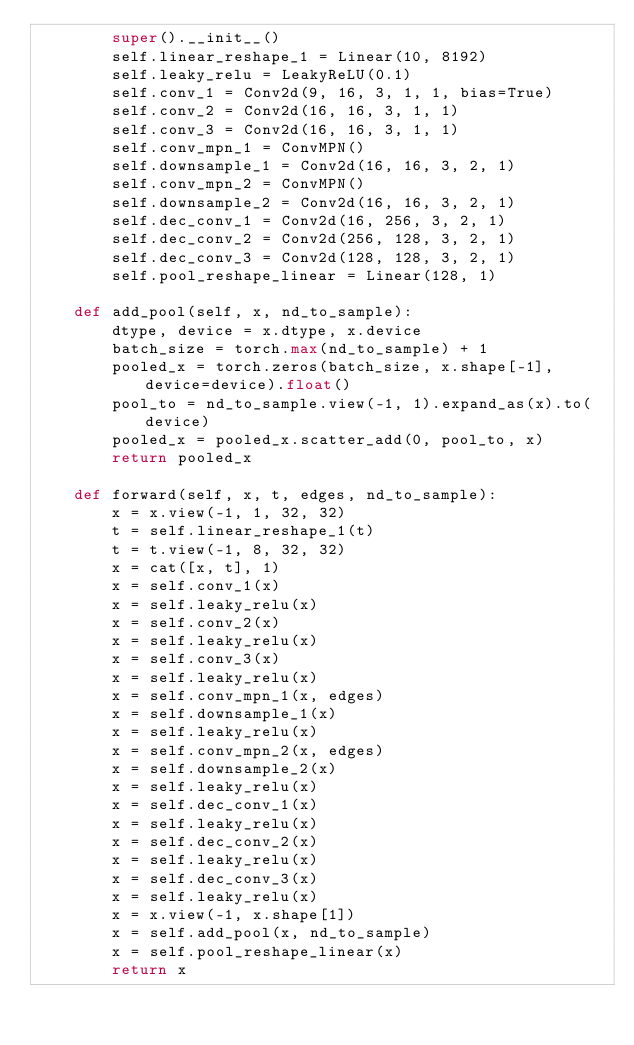<code> <loc_0><loc_0><loc_500><loc_500><_Python_>        super().__init__()
        self.linear_reshape_1 = Linear(10, 8192)
        self.leaky_relu = LeakyReLU(0.1)
        self.conv_1 = Conv2d(9, 16, 3, 1, 1, bias=True)
        self.conv_2 = Conv2d(16, 16, 3, 1, 1)
        self.conv_3 = Conv2d(16, 16, 3, 1, 1)
        self.conv_mpn_1 = ConvMPN()
        self.downsample_1 = Conv2d(16, 16, 3, 2, 1)
        self.conv_mpn_2 = ConvMPN()
        self.downsample_2 = Conv2d(16, 16, 3, 2, 1)
        self.dec_conv_1 = Conv2d(16, 256, 3, 2, 1)
        self.dec_conv_2 = Conv2d(256, 128, 3, 2, 1)
        self.dec_conv_3 = Conv2d(128, 128, 3, 2, 1)
        self.pool_reshape_linear = Linear(128, 1)

    def add_pool(self, x, nd_to_sample):
        dtype, device = x.dtype, x.device
        batch_size = torch.max(nd_to_sample) + 1
        pooled_x = torch.zeros(batch_size, x.shape[-1], device=device).float()
        pool_to = nd_to_sample.view(-1, 1).expand_as(x).to(device)
        pooled_x = pooled_x.scatter_add(0, pool_to, x)
        return pooled_x

    def forward(self, x, t, edges, nd_to_sample):
        x = x.view(-1, 1, 32, 32)
        t = self.linear_reshape_1(t)
        t = t.view(-1, 8, 32, 32)
        x = cat([x, t], 1)
        x = self.conv_1(x)
        x = self.leaky_relu(x)
        x = self.conv_2(x)
        x = self.leaky_relu(x)
        x = self.conv_3(x)
        x = self.leaky_relu(x)
        x = self.conv_mpn_1(x, edges)
        x = self.downsample_1(x)
        x = self.leaky_relu(x)
        x = self.conv_mpn_2(x, edges)
        x = self.downsample_2(x)
        x = self.leaky_relu(x)
        x = self.dec_conv_1(x)
        x = self.leaky_relu(x)
        x = self.dec_conv_2(x)
        x = self.leaky_relu(x)
        x = self.dec_conv_3(x)
        x = self.leaky_relu(x)
        x = x.view(-1, x.shape[1])
        x = self.add_pool(x, nd_to_sample)
        x = self.pool_reshape_linear(x)
        return x
</code> 